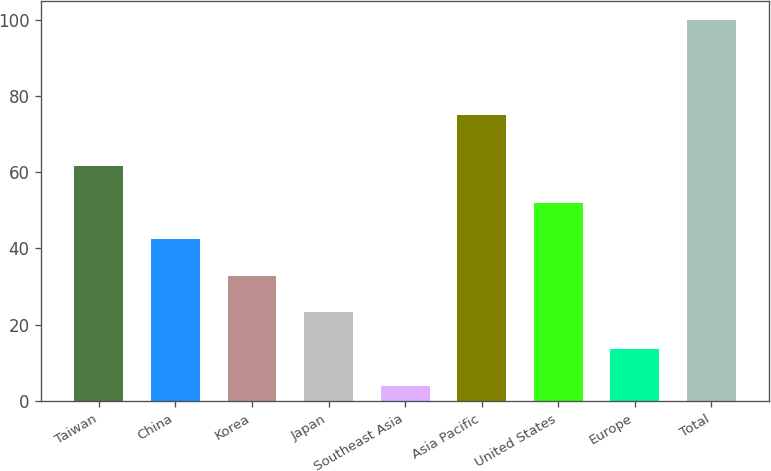Convert chart. <chart><loc_0><loc_0><loc_500><loc_500><bar_chart><fcel>Taiwan<fcel>China<fcel>Korea<fcel>Japan<fcel>Southeast Asia<fcel>Asia Pacific<fcel>United States<fcel>Europe<fcel>Total<nl><fcel>61.6<fcel>42.4<fcel>32.8<fcel>23.2<fcel>4<fcel>75<fcel>52<fcel>13.6<fcel>100<nl></chart> 